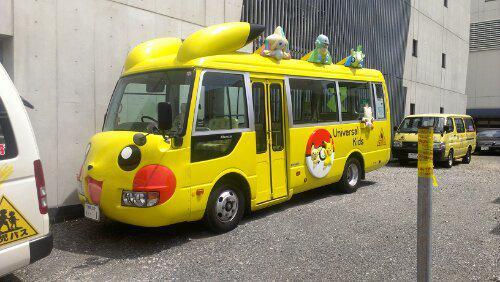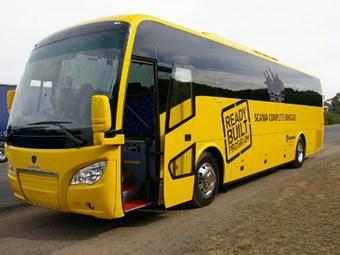The first image is the image on the left, the second image is the image on the right. For the images shown, is this caption "A bus with sculpted cartoon characters across the top is visible." true? Answer yes or no. Yes. The first image is the image on the left, the second image is the image on the right. For the images shown, is this caption "One bus has cartoon characters on the roof." true? Answer yes or no. Yes. 